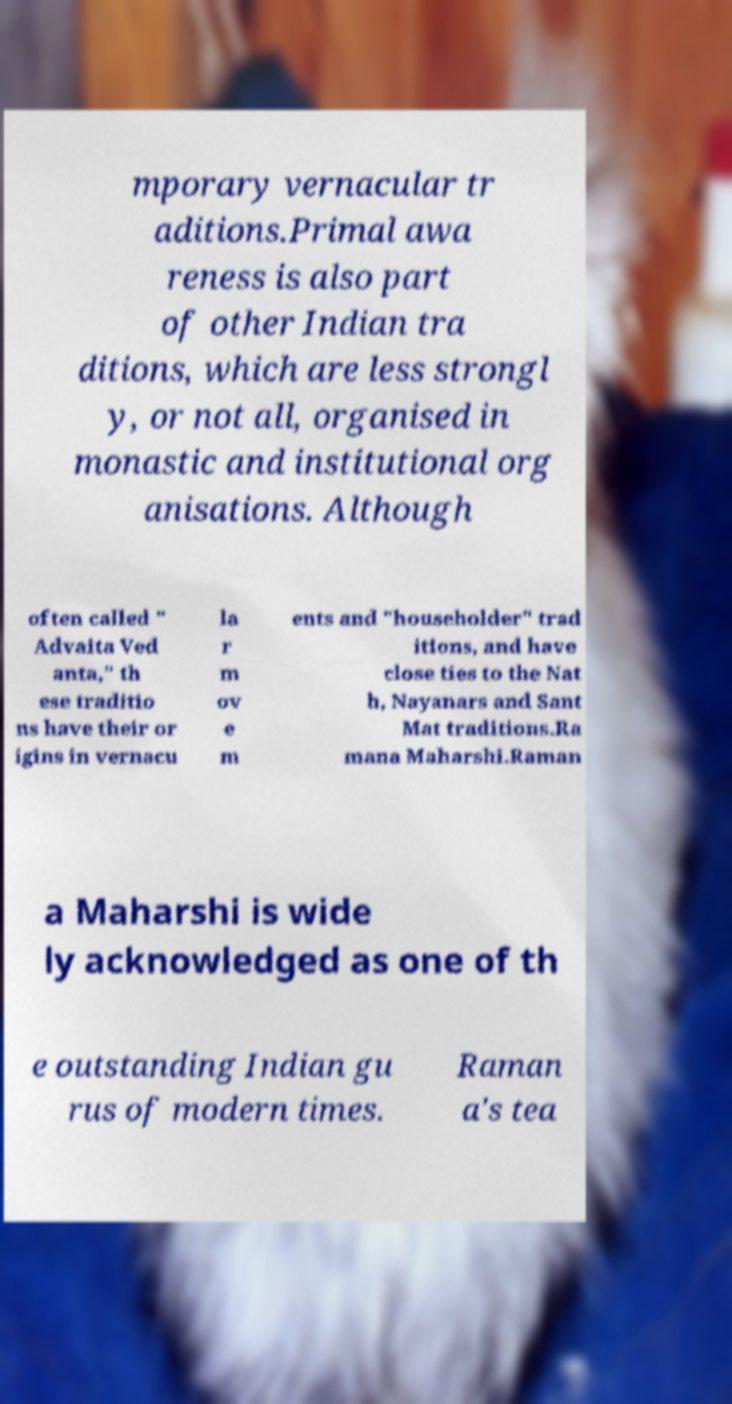There's text embedded in this image that I need extracted. Can you transcribe it verbatim? mporary vernacular tr aditions.Primal awa reness is also part of other Indian tra ditions, which are less strongl y, or not all, organised in monastic and institutional org anisations. Although often called " Advaita Ved anta," th ese traditio ns have their or igins in vernacu la r m ov e m ents and "householder" trad itions, and have close ties to the Nat h, Nayanars and Sant Mat traditions.Ra mana Maharshi.Raman a Maharshi is wide ly acknowledged as one of th e outstanding Indian gu rus of modern times. Raman a's tea 